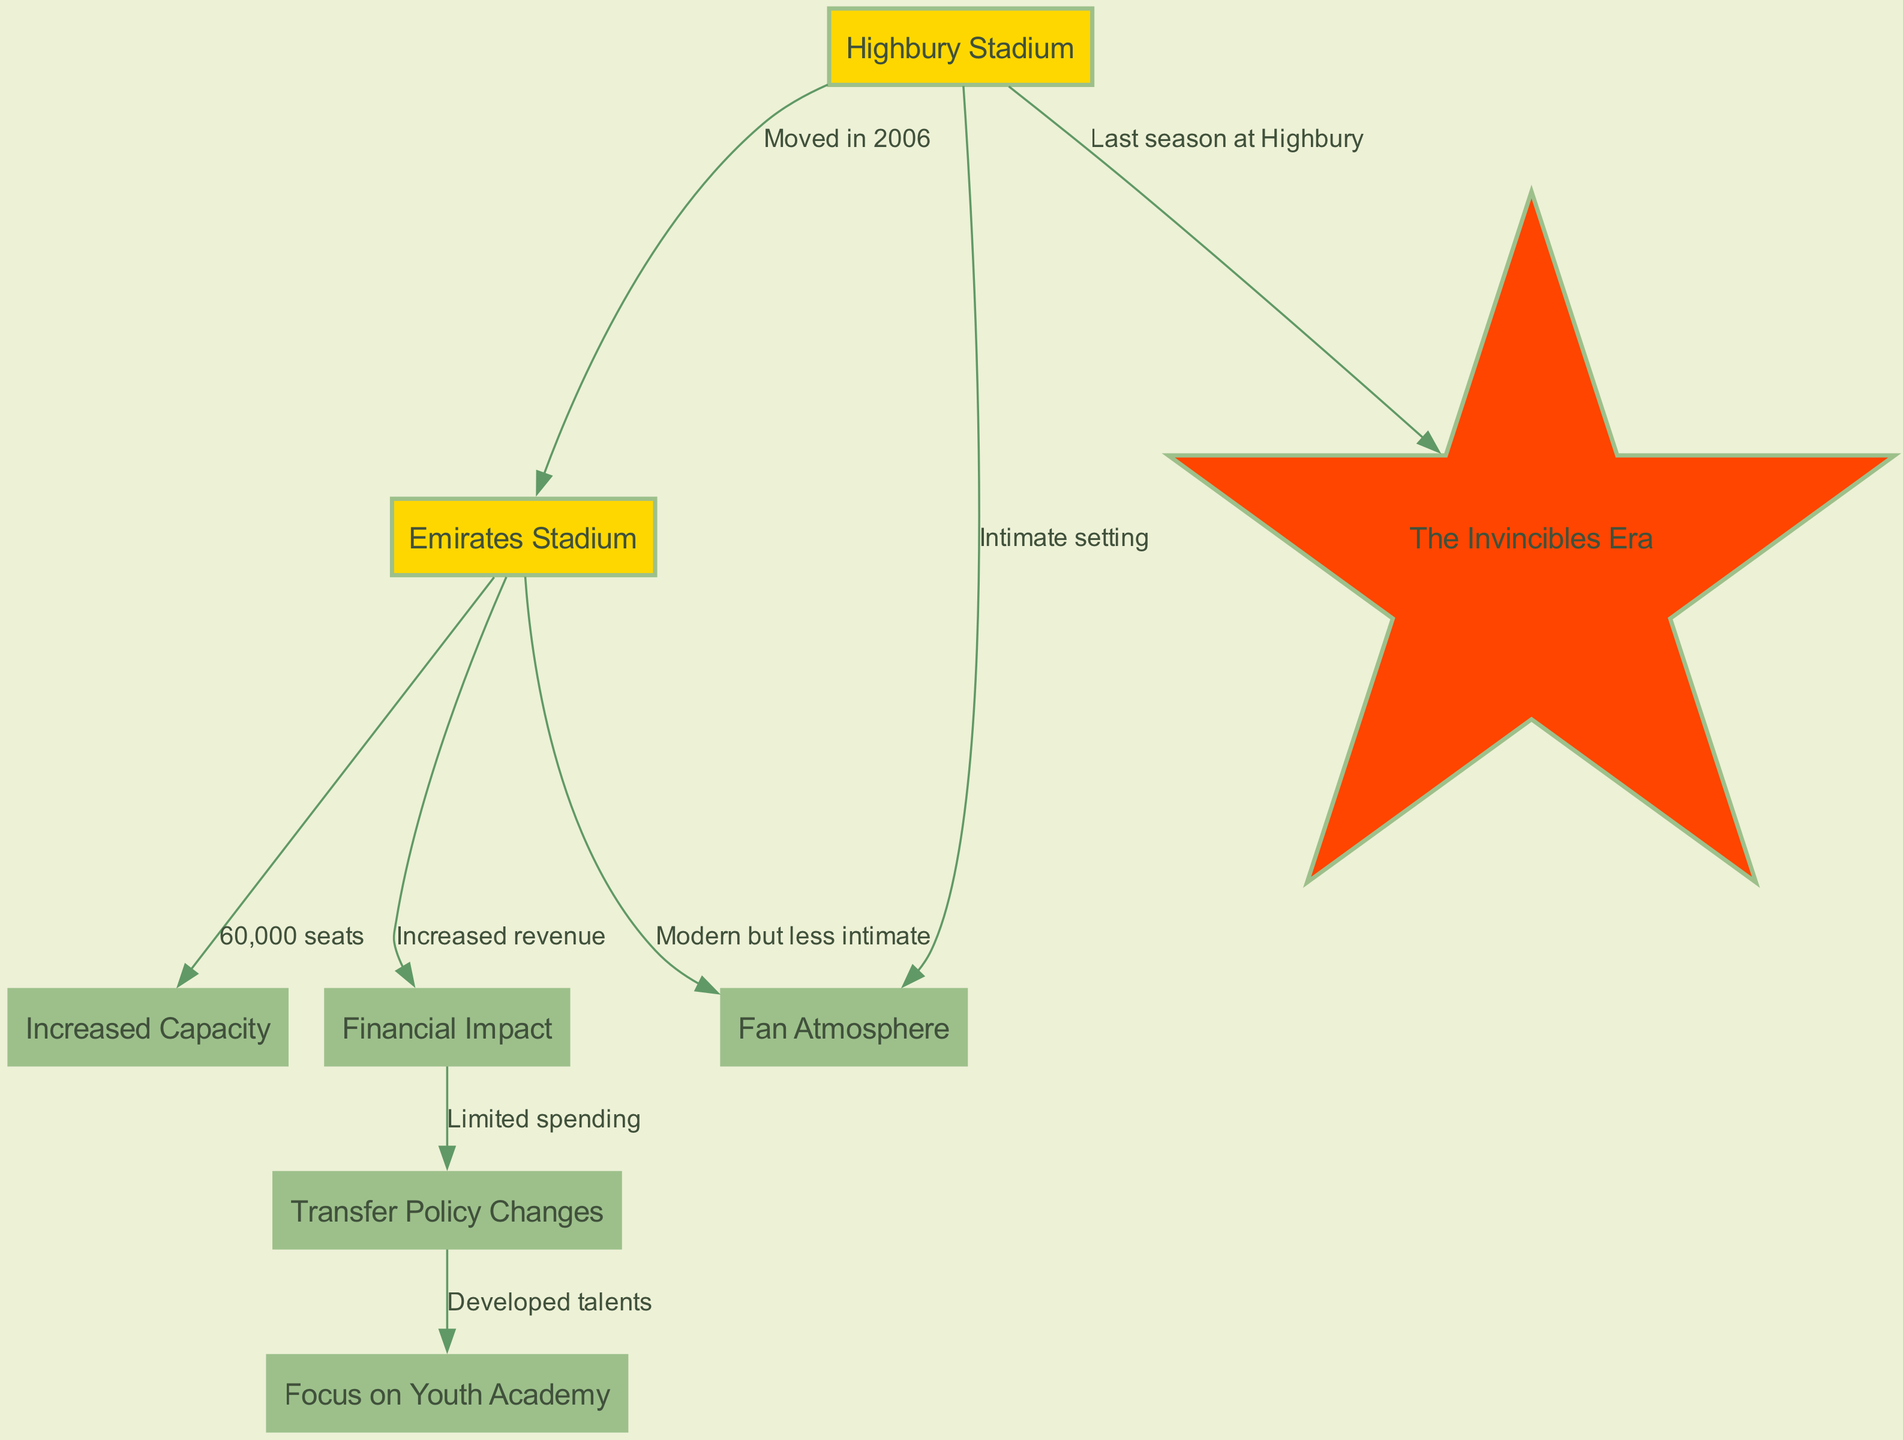What year did Arsenal move to the Emirates Stadium? The diagram specifies that the move from Highbury to Emirates Stadium occurred in 2006. Therefore, the answer is derived directly from the label on the edge connecting the nodes.
Answer: 2006 What is the seating capacity of the Emirates Stadium? The diagram indicates that the Emirates Stadium has a seating capacity of 60,000 seats, which is noted as a value connected to the Emirates node.
Answer: 60,000 seats How did the relocation to the Emirates Stadium affect club finances? According to the diagram, the transition to the Emirates Stadium resulted in increased revenue for the club. This is indicated by the edge connecting the Emirates node to the finances node.
Answer: Increased revenue What was the atmosphere like at Highbury Stadium? The diagram describes the atmosphere at Highbury Stadium as an "Intimate setting." This detail is highlighted through the connection between the Highbury node and the atmosphere node.
Answer: Intimate setting What impact did the financial situation have on Arsenal's transfer policy? The diagram states that the financial impact led to limited spending in the transfer policy. This conclusion is drawn from the connection between the finances node and the transfer_policy node.
Answer: Limited spending How did Arsenal adapt their player development strategy after moving to the Emirates? The diagram shows that the developments in the transfer policy, influenced by finances, led to a focus on developing talents through the youth academy, which connects the transfer_policy node to the youth_academy node.
Answer: Developed talents What notable era coincided with Arsenal's last season at Highbury? The diagram notes that the Invincibles era was associated with Arsenal's final season at Highbury Stadium. This connection is explicitly illustrated between the Highbury node and the invincibles node.
Answer: The Invincibles Era What change occurred in fan atmosphere after moving to the Emirates? The atmosphere transformed from an intimate setting at Highbury to being modern but less intimate at the Emirates Stadium, as indicated by the connections from both the Highbury and Emirates nodes to the atmosphere node.
Answer: Modern but less intimate 